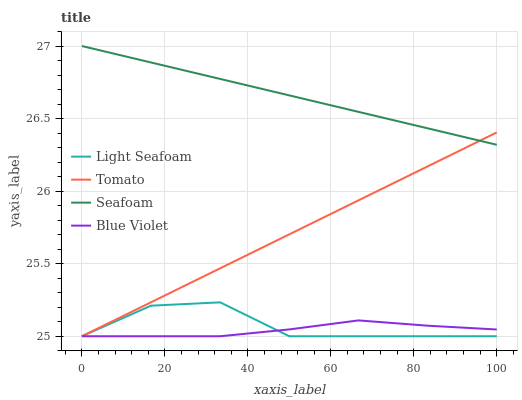Does Blue Violet have the minimum area under the curve?
Answer yes or no. Yes. Does Seafoam have the maximum area under the curve?
Answer yes or no. Yes. Does Light Seafoam have the minimum area under the curve?
Answer yes or no. No. Does Light Seafoam have the maximum area under the curve?
Answer yes or no. No. Is Tomato the smoothest?
Answer yes or no. Yes. Is Light Seafoam the roughest?
Answer yes or no. Yes. Is Seafoam the smoothest?
Answer yes or no. No. Is Seafoam the roughest?
Answer yes or no. No. Does Seafoam have the lowest value?
Answer yes or no. No. Does Seafoam have the highest value?
Answer yes or no. Yes. Does Light Seafoam have the highest value?
Answer yes or no. No. Is Light Seafoam less than Seafoam?
Answer yes or no. Yes. Is Seafoam greater than Blue Violet?
Answer yes or no. Yes. Does Light Seafoam intersect Blue Violet?
Answer yes or no. Yes. Is Light Seafoam less than Blue Violet?
Answer yes or no. No. Is Light Seafoam greater than Blue Violet?
Answer yes or no. No. Does Light Seafoam intersect Seafoam?
Answer yes or no. No. 